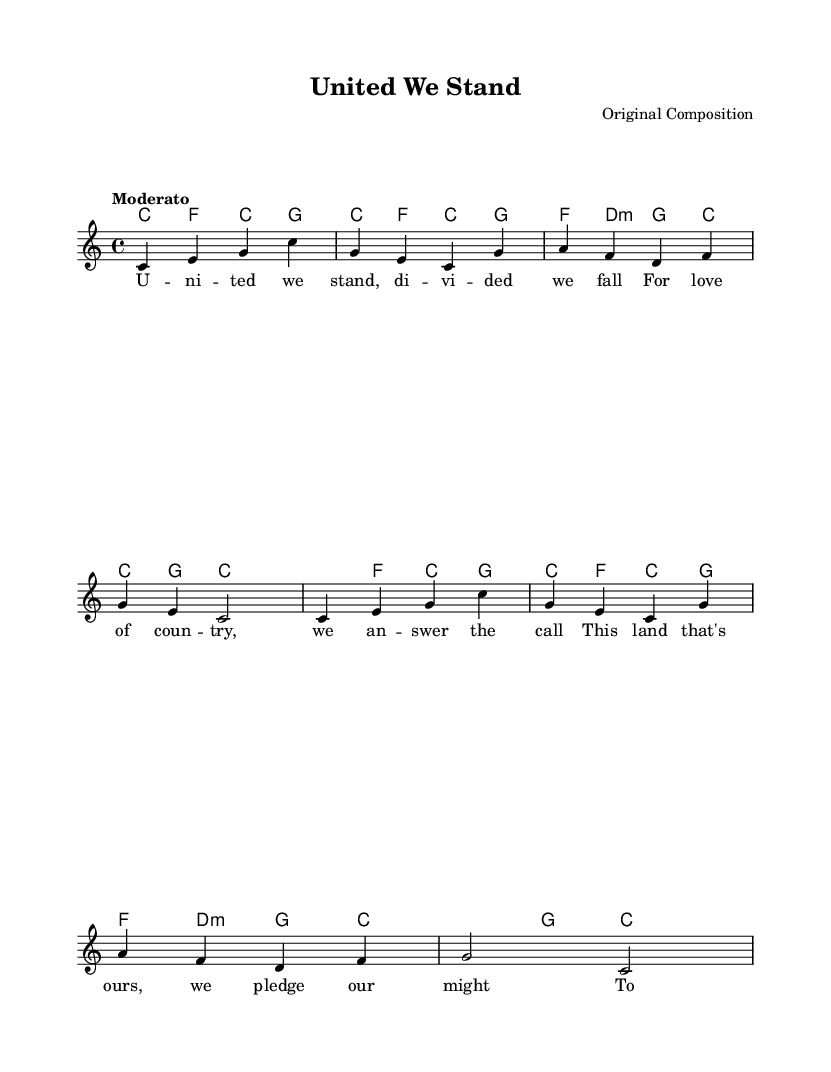What is the key signature of this music? The key signature is C major, which is indicated by the absence of sharps and flats.
Answer: C major What is the time signature of the piece? The time signature is 4/4, shown at the beginning of the score and indicating four beats per measure.
Answer: 4/4 What is the tempo marking indicated? The tempo marking states "Moderato," which directs musicians to perform at a moderate pace.
Answer: Moderato How many measures are in the melody? By counting the distinct sets of notes separated by bar lines, there are a total of 8 measures in the melody.
Answer: 8 What phrase is repeated in the music? The lyric phrase "U - ni - ted we stand" appears multiple times, indicating a recurring theme in the anthem.
Answer: U - ni - ted we stand What type of harmony is used in this piece? The harmony consists of simple chords primarily in major and minor forms, typical of a patriotic anthem structure.
Answer: Major and minor chords 